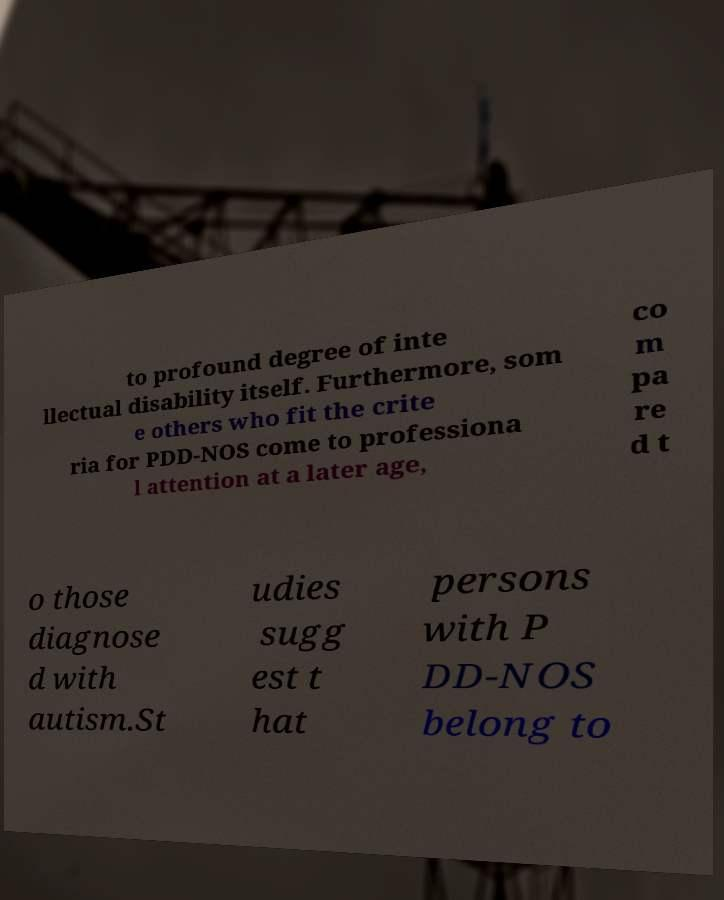For documentation purposes, I need the text within this image transcribed. Could you provide that? to profound degree of inte llectual disability itself. Furthermore, som e others who fit the crite ria for PDD-NOS come to professiona l attention at a later age, co m pa re d t o those diagnose d with autism.St udies sugg est t hat persons with P DD-NOS belong to 